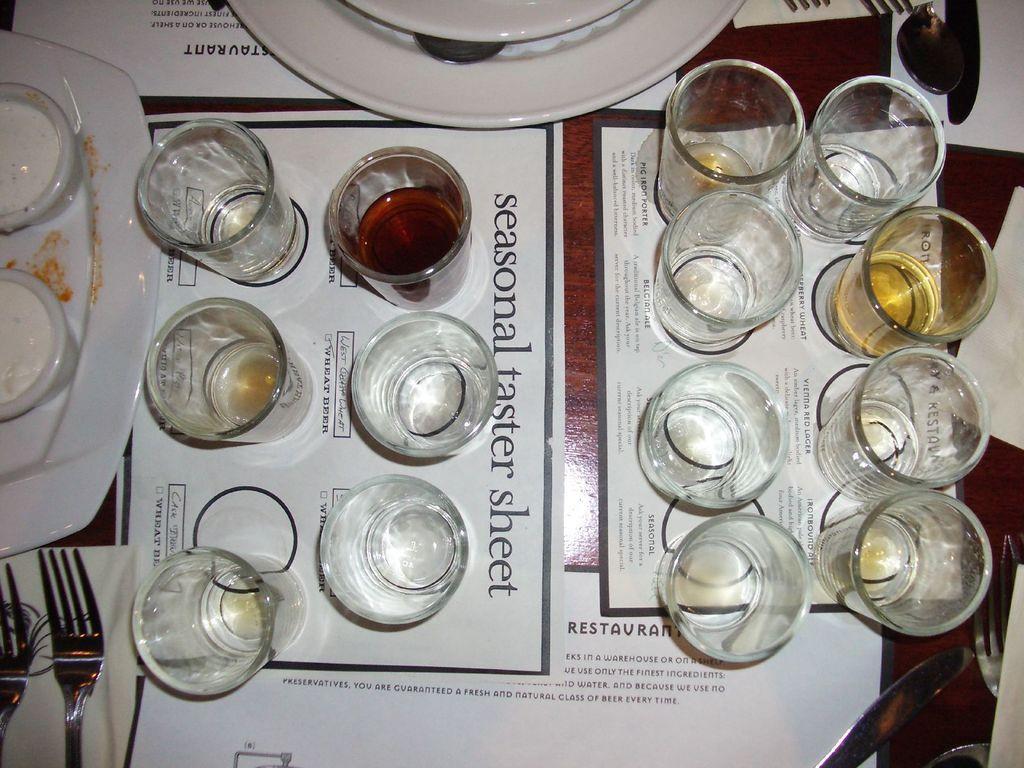Could you give a brief overview of what you see in this image? This picture shows few glasses on the table and we see a plate and couple of spoons and a knife and we see sauce in the bowls on a plate and we see couple of forks and papers on the table. 